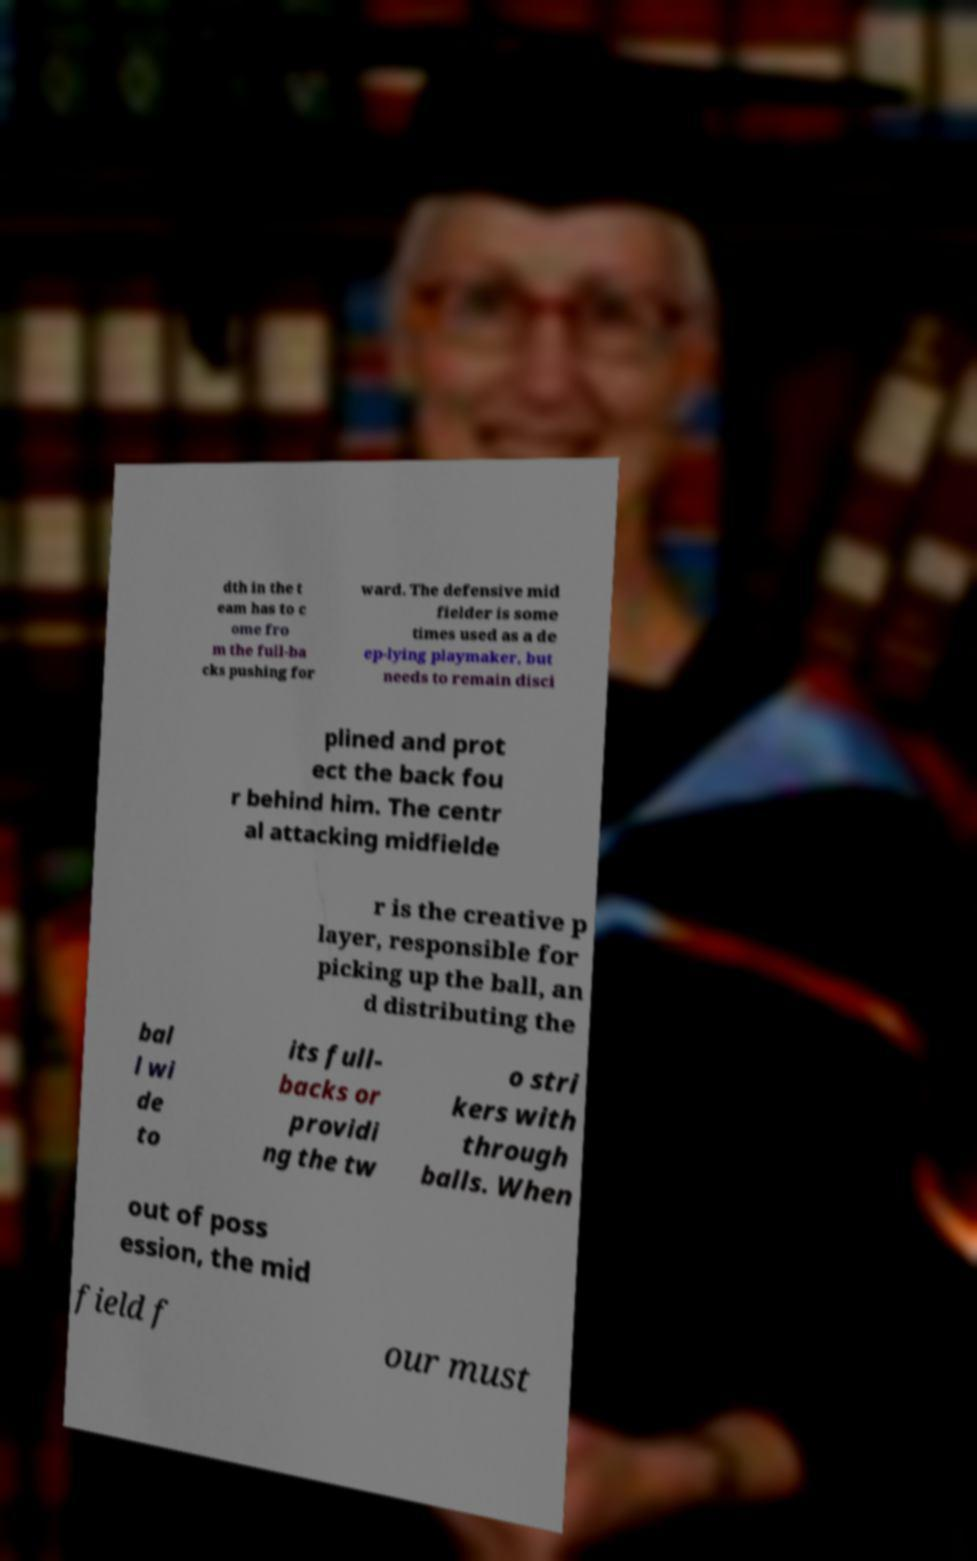For documentation purposes, I need the text within this image transcribed. Could you provide that? dth in the t eam has to c ome fro m the full-ba cks pushing for ward. The defensive mid fielder is some times used as a de ep-lying playmaker, but needs to remain disci plined and prot ect the back fou r behind him. The centr al attacking midfielde r is the creative p layer, responsible for picking up the ball, an d distributing the bal l wi de to its full- backs or providi ng the tw o stri kers with through balls. When out of poss ession, the mid field f our must 